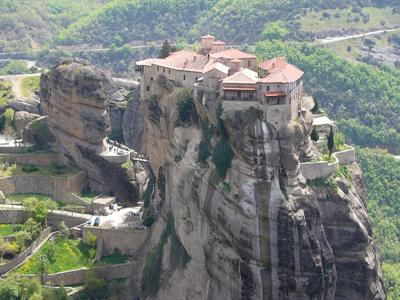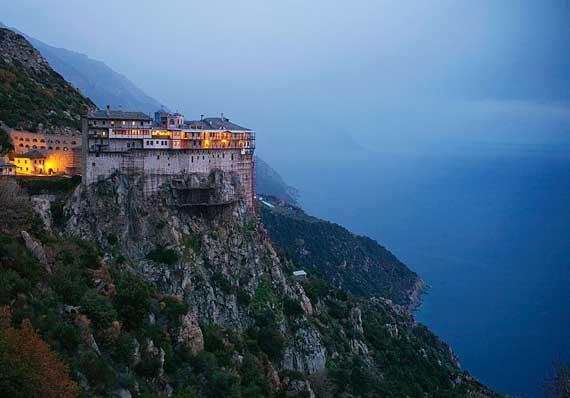The first image is the image on the left, the second image is the image on the right. Examine the images to the left and right. Is the description "There are hazy clouds in the image on the right." accurate? Answer yes or no. Yes. 